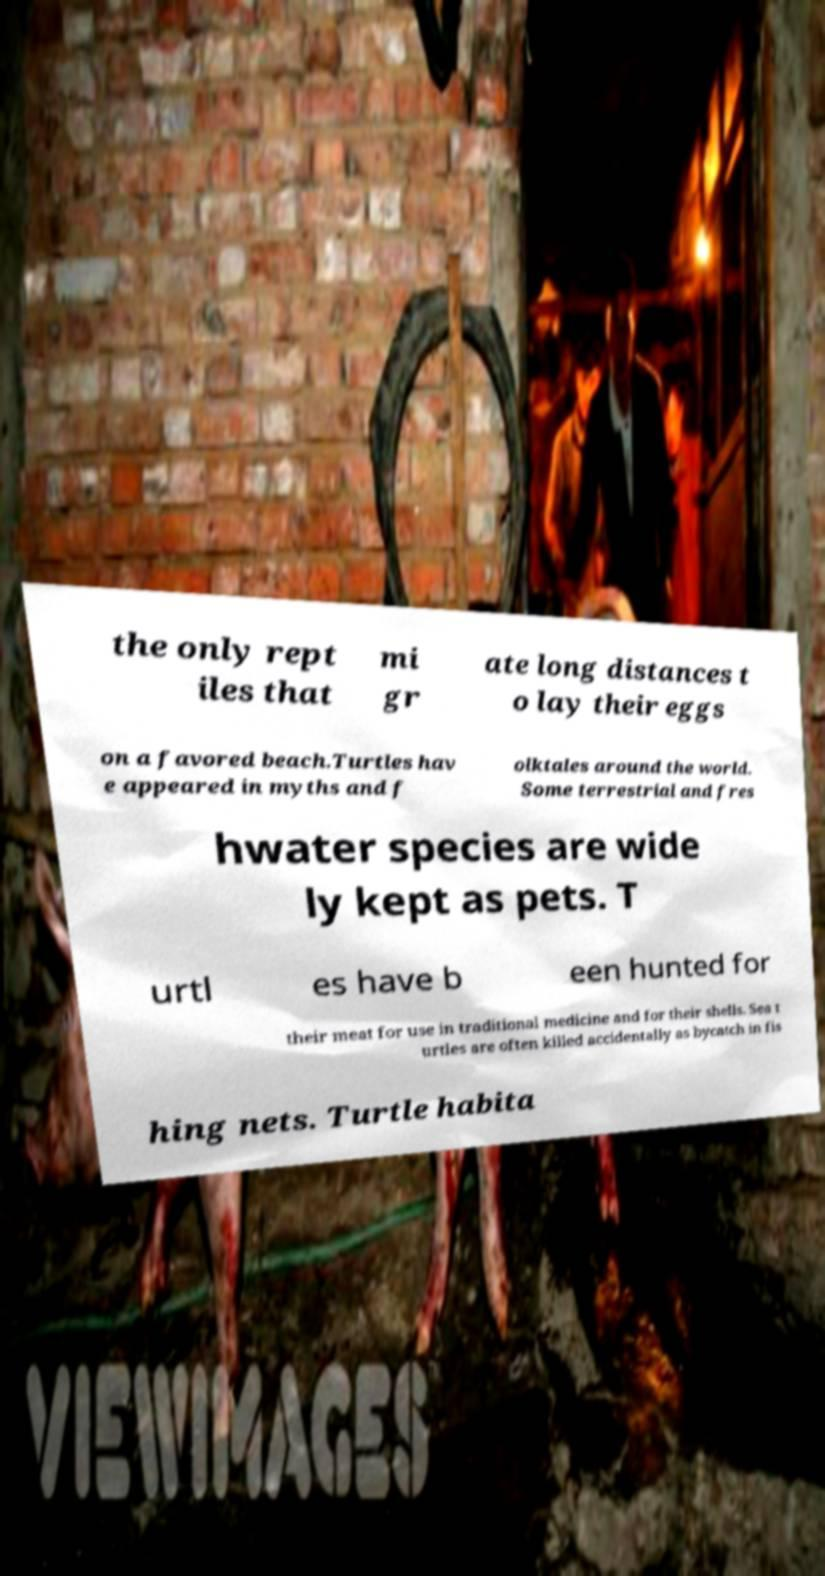Could you extract and type out the text from this image? the only rept iles that mi gr ate long distances t o lay their eggs on a favored beach.Turtles hav e appeared in myths and f olktales around the world. Some terrestrial and fres hwater species are wide ly kept as pets. T urtl es have b een hunted for their meat for use in traditional medicine and for their shells. Sea t urtles are often killed accidentally as bycatch in fis hing nets. Turtle habita 